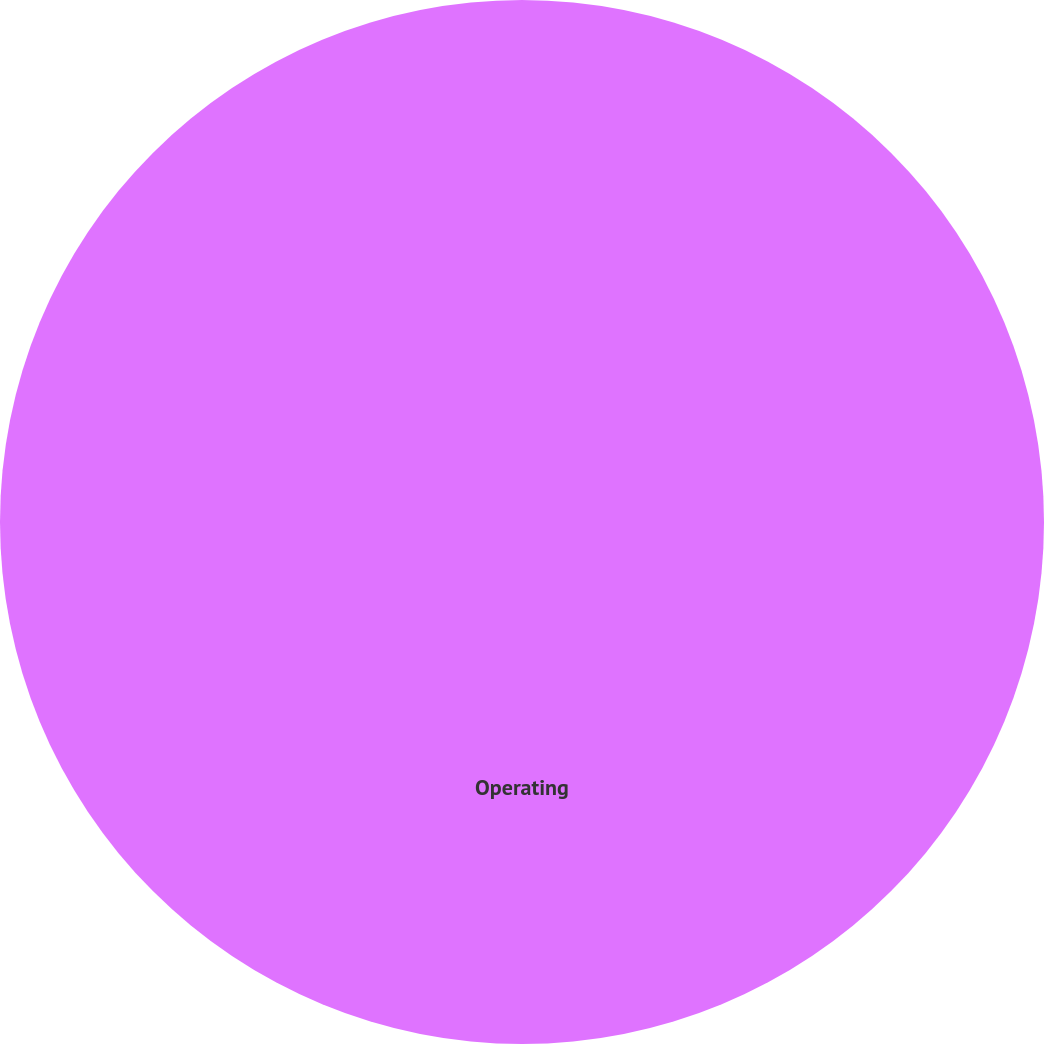Convert chart to OTSL. <chart><loc_0><loc_0><loc_500><loc_500><pie_chart><fcel>Operating<nl><fcel>100.0%<nl></chart> 